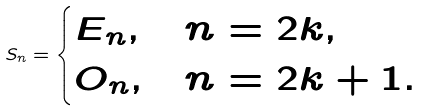<formula> <loc_0><loc_0><loc_500><loc_500>S _ { n } = \begin{cases} E _ { n } , & n = 2 k , \\ O _ { n } , & n = 2 k + 1 . \end{cases}</formula> 